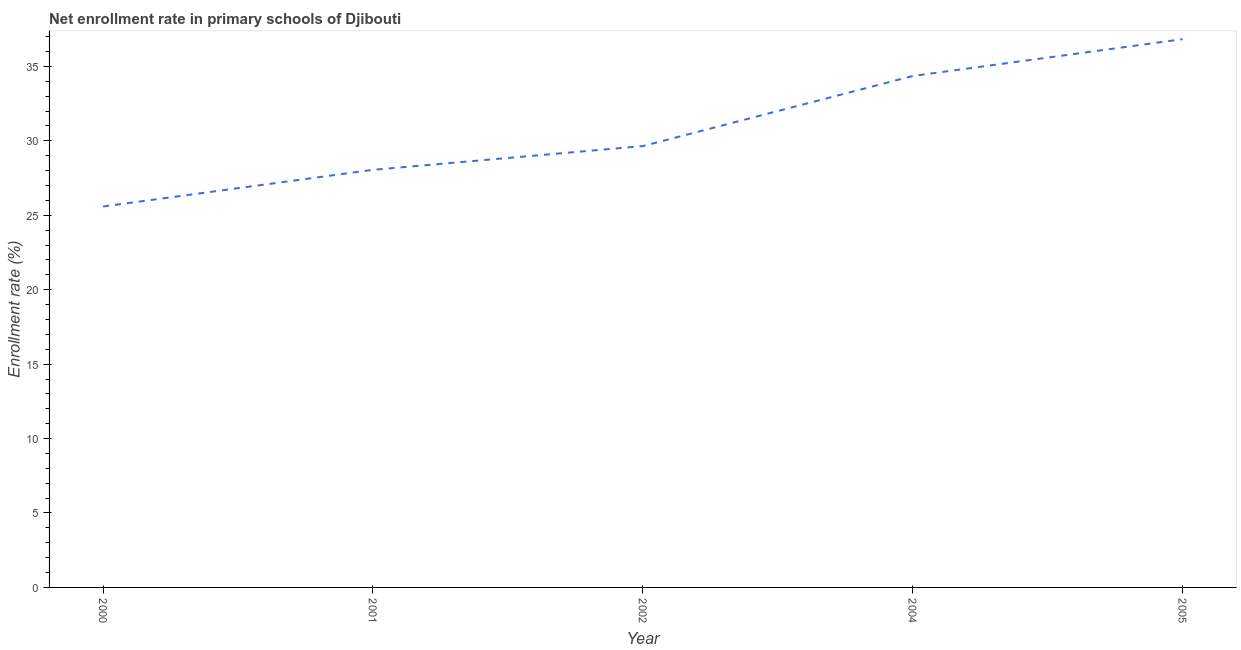What is the net enrollment rate in primary schools in 2000?
Make the answer very short. 25.59. Across all years, what is the maximum net enrollment rate in primary schools?
Provide a short and direct response. 36.83. Across all years, what is the minimum net enrollment rate in primary schools?
Offer a very short reply. 25.59. In which year was the net enrollment rate in primary schools maximum?
Keep it short and to the point. 2005. What is the sum of the net enrollment rate in primary schools?
Offer a terse response. 154.46. What is the difference between the net enrollment rate in primary schools in 2001 and 2002?
Provide a succinct answer. -1.6. What is the average net enrollment rate in primary schools per year?
Your answer should be very brief. 30.89. What is the median net enrollment rate in primary schools?
Your answer should be very brief. 29.65. Do a majority of the years between 2000 and 2005 (inclusive) have net enrollment rate in primary schools greater than 24 %?
Your answer should be very brief. Yes. What is the ratio of the net enrollment rate in primary schools in 2002 to that in 2004?
Keep it short and to the point. 0.86. Is the net enrollment rate in primary schools in 2001 less than that in 2002?
Provide a succinct answer. Yes. What is the difference between the highest and the second highest net enrollment rate in primary schools?
Provide a succinct answer. 2.47. What is the difference between the highest and the lowest net enrollment rate in primary schools?
Provide a short and direct response. 11.24. Does the net enrollment rate in primary schools monotonically increase over the years?
Provide a short and direct response. Yes. What is the title of the graph?
Ensure brevity in your answer.  Net enrollment rate in primary schools of Djibouti. What is the label or title of the X-axis?
Offer a terse response. Year. What is the label or title of the Y-axis?
Your answer should be compact. Enrollment rate (%). What is the Enrollment rate (%) in 2000?
Provide a succinct answer. 25.59. What is the Enrollment rate (%) of 2001?
Make the answer very short. 28.05. What is the Enrollment rate (%) in 2002?
Provide a succinct answer. 29.65. What is the Enrollment rate (%) of 2004?
Give a very brief answer. 34.35. What is the Enrollment rate (%) in 2005?
Provide a succinct answer. 36.83. What is the difference between the Enrollment rate (%) in 2000 and 2001?
Provide a short and direct response. -2.46. What is the difference between the Enrollment rate (%) in 2000 and 2002?
Offer a very short reply. -4.06. What is the difference between the Enrollment rate (%) in 2000 and 2004?
Your answer should be very brief. -8.76. What is the difference between the Enrollment rate (%) in 2000 and 2005?
Keep it short and to the point. -11.24. What is the difference between the Enrollment rate (%) in 2001 and 2002?
Give a very brief answer. -1.6. What is the difference between the Enrollment rate (%) in 2001 and 2004?
Your answer should be compact. -6.3. What is the difference between the Enrollment rate (%) in 2001 and 2005?
Keep it short and to the point. -8.78. What is the difference between the Enrollment rate (%) in 2002 and 2004?
Offer a very short reply. -4.71. What is the difference between the Enrollment rate (%) in 2002 and 2005?
Give a very brief answer. -7.18. What is the difference between the Enrollment rate (%) in 2004 and 2005?
Ensure brevity in your answer.  -2.47. What is the ratio of the Enrollment rate (%) in 2000 to that in 2001?
Give a very brief answer. 0.91. What is the ratio of the Enrollment rate (%) in 2000 to that in 2002?
Your answer should be very brief. 0.86. What is the ratio of the Enrollment rate (%) in 2000 to that in 2004?
Your answer should be compact. 0.74. What is the ratio of the Enrollment rate (%) in 2000 to that in 2005?
Make the answer very short. 0.69. What is the ratio of the Enrollment rate (%) in 2001 to that in 2002?
Give a very brief answer. 0.95. What is the ratio of the Enrollment rate (%) in 2001 to that in 2004?
Your answer should be very brief. 0.82. What is the ratio of the Enrollment rate (%) in 2001 to that in 2005?
Provide a succinct answer. 0.76. What is the ratio of the Enrollment rate (%) in 2002 to that in 2004?
Your answer should be very brief. 0.86. What is the ratio of the Enrollment rate (%) in 2002 to that in 2005?
Your answer should be very brief. 0.81. What is the ratio of the Enrollment rate (%) in 2004 to that in 2005?
Your answer should be very brief. 0.93. 